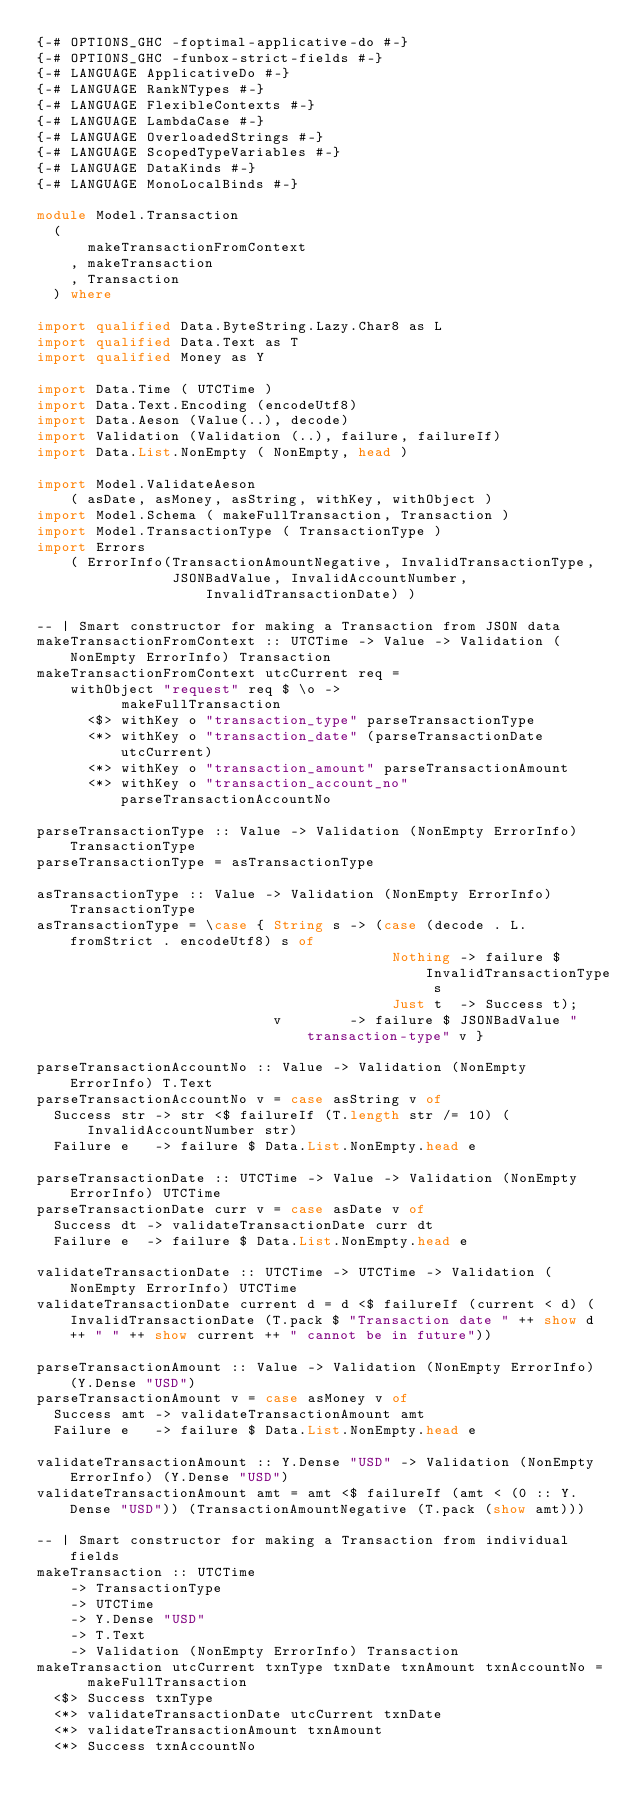Convert code to text. <code><loc_0><loc_0><loc_500><loc_500><_Haskell_>{-# OPTIONS_GHC -foptimal-applicative-do #-}
{-# OPTIONS_GHC -funbox-strict-fields #-}
{-# LANGUAGE ApplicativeDo #-}
{-# LANGUAGE RankNTypes #-}
{-# LANGUAGE FlexibleContexts #-}
{-# LANGUAGE LambdaCase #-}
{-# LANGUAGE OverloadedStrings #-}
{-# LANGUAGE ScopedTypeVariables #-}
{-# LANGUAGE DataKinds #-}
{-# LANGUAGE MonoLocalBinds #-}

module Model.Transaction 
  (
      makeTransactionFromContext
    , makeTransaction
    , Transaction
  ) where

import qualified Data.ByteString.Lazy.Char8 as L
import qualified Data.Text as T
import qualified Money as Y

import Data.Time ( UTCTime )
import Data.Text.Encoding (encodeUtf8)
import Data.Aeson (Value(..), decode)
import Validation (Validation (..), failure, failureIf)
import Data.List.NonEmpty ( NonEmpty, head )

import Model.ValidateAeson
    ( asDate, asMoney, asString, withKey, withObject )
import Model.Schema ( makeFullTransaction, Transaction )
import Model.TransactionType ( TransactionType )
import Errors
    ( ErrorInfo(TransactionAmountNegative, InvalidTransactionType,
                JSONBadValue, InvalidAccountNumber, InvalidTransactionDate) )

-- | Smart constructor for making a Transaction from JSON data
makeTransactionFromContext :: UTCTime -> Value -> Validation (NonEmpty ErrorInfo) Transaction
makeTransactionFromContext utcCurrent req = 
    withObject "request" req $ \o -> 
          makeFullTransaction 
      <$> withKey o "transaction_type" parseTransactionType 
      <*> withKey o "transaction_date" (parseTransactionDate utcCurrent)
      <*> withKey o "transaction_amount" parseTransactionAmount
      <*> withKey o "transaction_account_no" parseTransactionAccountNo

parseTransactionType :: Value -> Validation (NonEmpty ErrorInfo) TransactionType
parseTransactionType = asTransactionType
      
asTransactionType :: Value -> Validation (NonEmpty ErrorInfo) TransactionType
asTransactionType = \case { String s -> (case (decode . L.fromStrict . encodeUtf8) s of 
                                          Nothing -> failure $ InvalidTransactionType s
                                          Just t  -> Success t);
                            v        -> failure $ JSONBadValue "transaction-type" v }

parseTransactionAccountNo :: Value -> Validation (NonEmpty ErrorInfo) T.Text
parseTransactionAccountNo v = case asString v of
  Success str -> str <$ failureIf (T.length str /= 10) (InvalidAccountNumber str)
  Failure e   -> failure $ Data.List.NonEmpty.head e

parseTransactionDate :: UTCTime -> Value -> Validation (NonEmpty ErrorInfo) UTCTime
parseTransactionDate curr v = case asDate v of
  Success dt -> validateTransactionDate curr dt
  Failure e  -> failure $ Data.List.NonEmpty.head e
      
validateTransactionDate :: UTCTime -> UTCTime -> Validation (NonEmpty ErrorInfo) UTCTime
validateTransactionDate current d = d <$ failureIf (current < d) (InvalidTransactionDate (T.pack $ "Transaction date " ++ show d ++ " " ++ show current ++ " cannot be in future"))
      
parseTransactionAmount :: Value -> Validation (NonEmpty ErrorInfo) (Y.Dense "USD")
parseTransactionAmount v = case asMoney v of
  Success amt -> validateTransactionAmount amt
  Failure e   -> failure $ Data.List.NonEmpty.head e
      
validateTransactionAmount :: Y.Dense "USD" -> Validation (NonEmpty ErrorInfo) (Y.Dense "USD")
validateTransactionAmount amt = amt <$ failureIf (amt < (0 :: Y.Dense "USD")) (TransactionAmountNegative (T.pack (show amt)))

-- | Smart constructor for making a Transaction from individual fields
makeTransaction :: UTCTime 
    -> TransactionType
    -> UTCTime 
    -> Y.Dense "USD"
    -> T.Text
    -> Validation (NonEmpty ErrorInfo) Transaction
makeTransaction utcCurrent txnType txnDate txnAmount txnAccountNo =
      makeFullTransaction 
  <$> Success txnType
  <*> validateTransactionDate utcCurrent txnDate
  <*> validateTransactionAmount txnAmount
  <*> Success txnAccountNo</code> 